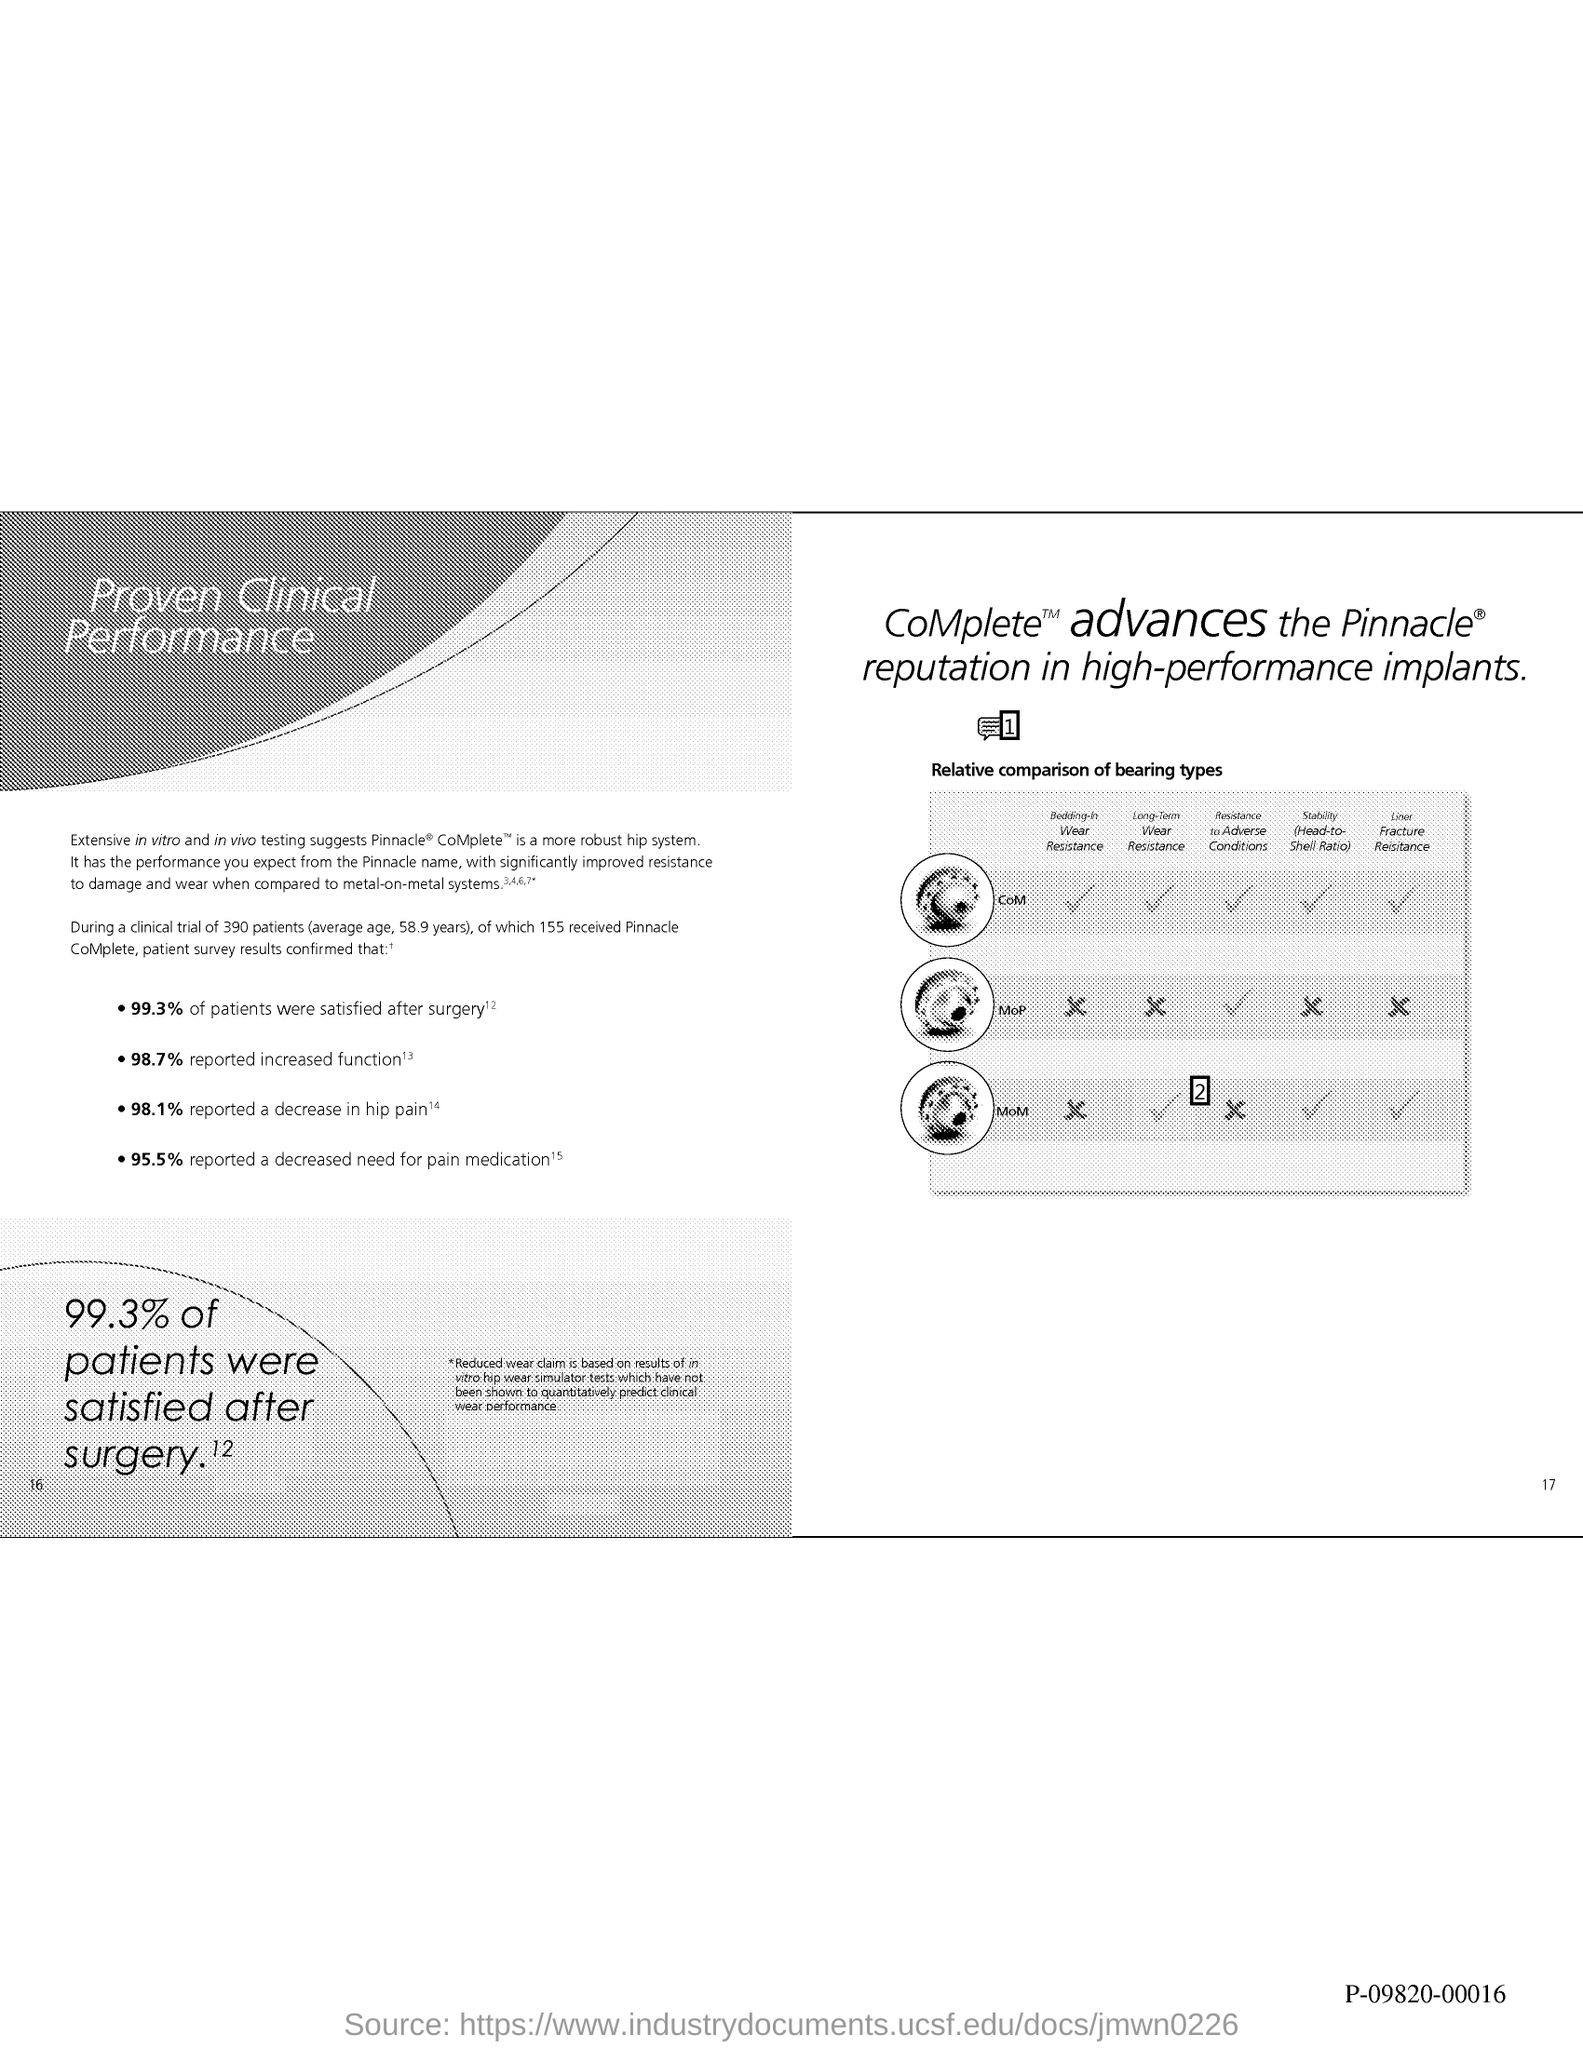What is the number at bottom right of the page?
Provide a short and direct response. 17. What is the percent of patients satisfied after surgery ?
Offer a very short reply. 99.3%. What is the percent of reported increased function ?
Give a very brief answer. 98.7%. What is the percent reported a decrease in hip pain ?
Keep it short and to the point. 98.1%. What is the percent reported a decreased need for pain medication ?
Your answer should be very brief. 95.5%. 